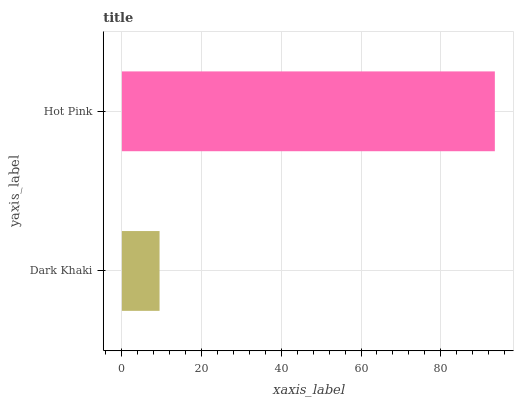Is Dark Khaki the minimum?
Answer yes or no. Yes. Is Hot Pink the maximum?
Answer yes or no. Yes. Is Hot Pink the minimum?
Answer yes or no. No. Is Hot Pink greater than Dark Khaki?
Answer yes or no. Yes. Is Dark Khaki less than Hot Pink?
Answer yes or no. Yes. Is Dark Khaki greater than Hot Pink?
Answer yes or no. No. Is Hot Pink less than Dark Khaki?
Answer yes or no. No. Is Hot Pink the high median?
Answer yes or no. Yes. Is Dark Khaki the low median?
Answer yes or no. Yes. Is Dark Khaki the high median?
Answer yes or no. No. Is Hot Pink the low median?
Answer yes or no. No. 